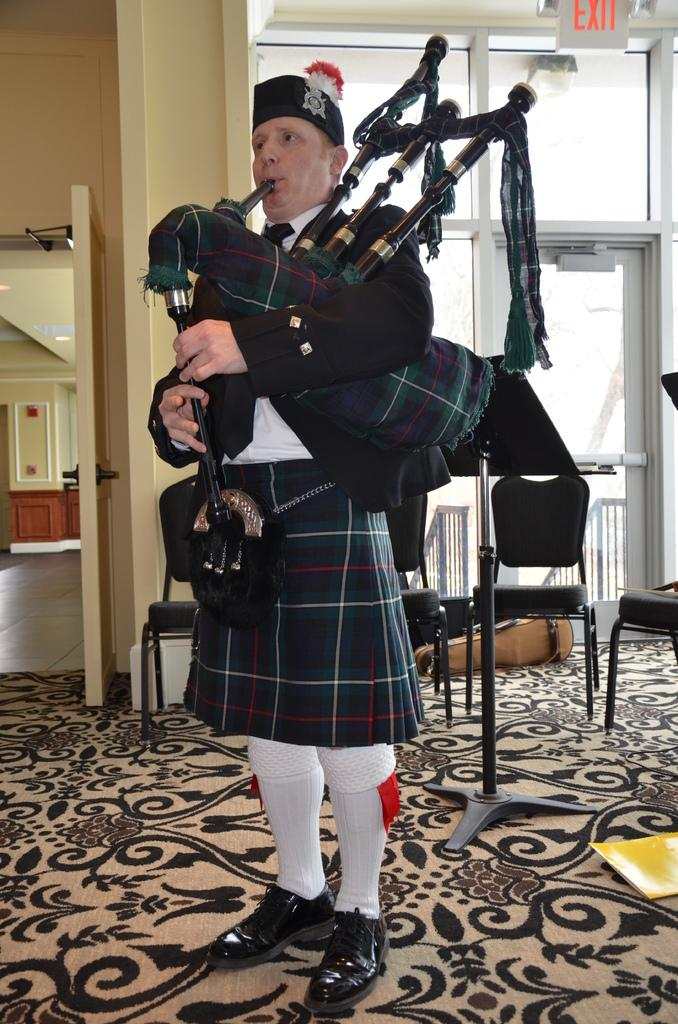What is the person in the image doing? The person is playing a trombone in the image. Can you describe the background of the image? There is a door to a wall in the background of the image. What type of bone is visible in the image? There is no bone present in the image; it features a person playing a trombone and a door to a wall in the background. 